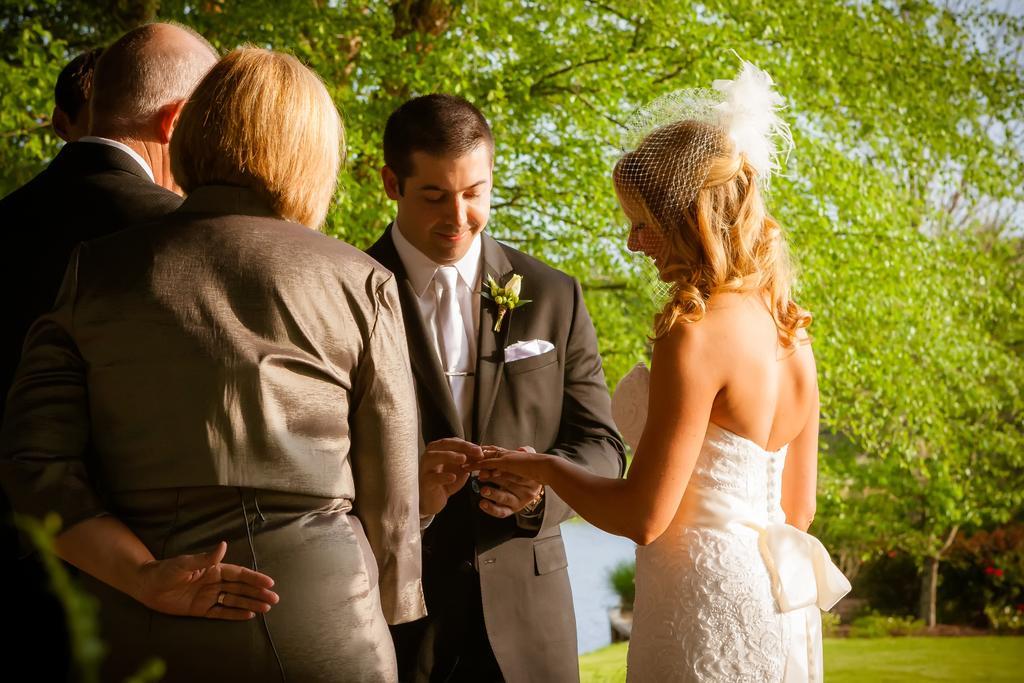How would you summarize this image in a sentence or two? In this image I can see group of people standing. The at right wearing white color dress and the person at left wearing black blazer, white shirt and white color tie, background I can see trees in green color and sky in blue color. 